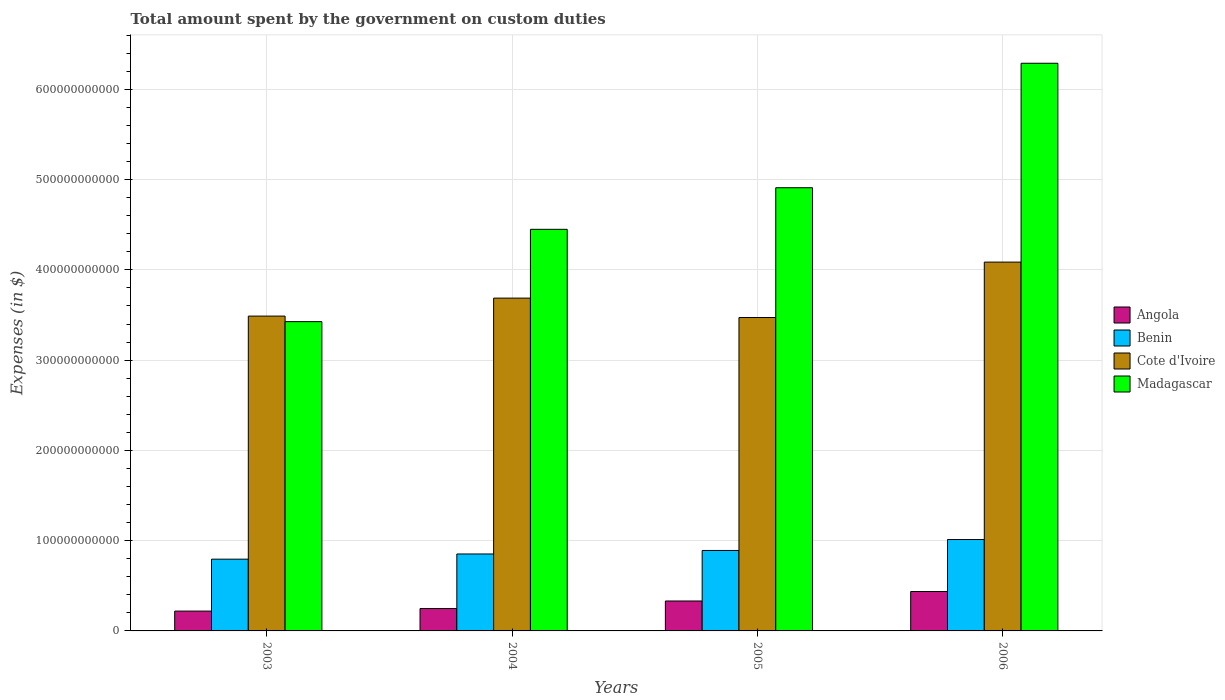Are the number of bars per tick equal to the number of legend labels?
Your answer should be very brief. Yes. Are the number of bars on each tick of the X-axis equal?
Your answer should be compact. Yes. What is the label of the 4th group of bars from the left?
Your response must be concise. 2006. What is the amount spent on custom duties by the government in Madagascar in 2006?
Provide a succinct answer. 6.29e+11. Across all years, what is the maximum amount spent on custom duties by the government in Madagascar?
Make the answer very short. 6.29e+11. Across all years, what is the minimum amount spent on custom duties by the government in Cote d'Ivoire?
Keep it short and to the point. 3.47e+11. In which year was the amount spent on custom duties by the government in Angola maximum?
Provide a short and direct response. 2006. In which year was the amount spent on custom duties by the government in Cote d'Ivoire minimum?
Give a very brief answer. 2005. What is the total amount spent on custom duties by the government in Cote d'Ivoire in the graph?
Your response must be concise. 1.47e+12. What is the difference between the amount spent on custom duties by the government in Cote d'Ivoire in 2005 and that in 2006?
Provide a succinct answer. -6.14e+1. What is the difference between the amount spent on custom duties by the government in Cote d'Ivoire in 2003 and the amount spent on custom duties by the government in Angola in 2005?
Make the answer very short. 3.16e+11. What is the average amount spent on custom duties by the government in Cote d'Ivoire per year?
Provide a short and direct response. 3.68e+11. In the year 2004, what is the difference between the amount spent on custom duties by the government in Cote d'Ivoire and amount spent on custom duties by the government in Madagascar?
Offer a very short reply. -7.62e+1. In how many years, is the amount spent on custom duties by the government in Angola greater than 600000000000 $?
Provide a succinct answer. 0. What is the ratio of the amount spent on custom duties by the government in Madagascar in 2003 to that in 2005?
Your answer should be very brief. 0.7. Is the difference between the amount spent on custom duties by the government in Cote d'Ivoire in 2003 and 2006 greater than the difference between the amount spent on custom duties by the government in Madagascar in 2003 and 2006?
Make the answer very short. Yes. What is the difference between the highest and the second highest amount spent on custom duties by the government in Cote d'Ivoire?
Your answer should be very brief. 3.99e+1. What is the difference between the highest and the lowest amount spent on custom duties by the government in Cote d'Ivoire?
Ensure brevity in your answer.  6.14e+1. In how many years, is the amount spent on custom duties by the government in Madagascar greater than the average amount spent on custom duties by the government in Madagascar taken over all years?
Provide a short and direct response. 2. What does the 4th bar from the left in 2006 represents?
Your response must be concise. Madagascar. What does the 1st bar from the right in 2004 represents?
Your answer should be compact. Madagascar. How many bars are there?
Offer a very short reply. 16. How many years are there in the graph?
Provide a succinct answer. 4. What is the difference between two consecutive major ticks on the Y-axis?
Ensure brevity in your answer.  1.00e+11. Are the values on the major ticks of Y-axis written in scientific E-notation?
Ensure brevity in your answer.  No. Does the graph contain any zero values?
Your answer should be very brief. No. Where does the legend appear in the graph?
Ensure brevity in your answer.  Center right. How are the legend labels stacked?
Give a very brief answer. Vertical. What is the title of the graph?
Your response must be concise. Total amount spent by the government on custom duties. What is the label or title of the X-axis?
Your answer should be compact. Years. What is the label or title of the Y-axis?
Offer a terse response. Expenses (in $). What is the Expenses (in $) of Angola in 2003?
Provide a succinct answer. 2.20e+1. What is the Expenses (in $) of Benin in 2003?
Keep it short and to the point. 7.95e+1. What is the Expenses (in $) in Cote d'Ivoire in 2003?
Provide a short and direct response. 3.49e+11. What is the Expenses (in $) of Madagascar in 2003?
Offer a terse response. 3.43e+11. What is the Expenses (in $) in Angola in 2004?
Offer a terse response. 2.48e+1. What is the Expenses (in $) of Benin in 2004?
Provide a short and direct response. 8.52e+1. What is the Expenses (in $) of Cote d'Ivoire in 2004?
Keep it short and to the point. 3.69e+11. What is the Expenses (in $) in Madagascar in 2004?
Offer a very short reply. 4.45e+11. What is the Expenses (in $) in Angola in 2005?
Make the answer very short. 3.32e+1. What is the Expenses (in $) of Benin in 2005?
Give a very brief answer. 8.91e+1. What is the Expenses (in $) in Cote d'Ivoire in 2005?
Your answer should be very brief. 3.47e+11. What is the Expenses (in $) in Madagascar in 2005?
Your answer should be very brief. 4.91e+11. What is the Expenses (in $) of Angola in 2006?
Provide a succinct answer. 4.37e+1. What is the Expenses (in $) in Benin in 2006?
Provide a succinct answer. 1.01e+11. What is the Expenses (in $) of Cote d'Ivoire in 2006?
Give a very brief answer. 4.09e+11. What is the Expenses (in $) in Madagascar in 2006?
Your answer should be compact. 6.29e+11. Across all years, what is the maximum Expenses (in $) of Angola?
Make the answer very short. 4.37e+1. Across all years, what is the maximum Expenses (in $) in Benin?
Provide a succinct answer. 1.01e+11. Across all years, what is the maximum Expenses (in $) of Cote d'Ivoire?
Ensure brevity in your answer.  4.09e+11. Across all years, what is the maximum Expenses (in $) of Madagascar?
Provide a short and direct response. 6.29e+11. Across all years, what is the minimum Expenses (in $) of Angola?
Your response must be concise. 2.20e+1. Across all years, what is the minimum Expenses (in $) of Benin?
Your answer should be very brief. 7.95e+1. Across all years, what is the minimum Expenses (in $) of Cote d'Ivoire?
Give a very brief answer. 3.47e+11. Across all years, what is the minimum Expenses (in $) in Madagascar?
Offer a very short reply. 3.43e+11. What is the total Expenses (in $) in Angola in the graph?
Offer a terse response. 1.24e+11. What is the total Expenses (in $) in Benin in the graph?
Give a very brief answer. 3.55e+11. What is the total Expenses (in $) in Cote d'Ivoire in the graph?
Ensure brevity in your answer.  1.47e+12. What is the total Expenses (in $) in Madagascar in the graph?
Keep it short and to the point. 1.91e+12. What is the difference between the Expenses (in $) in Angola in 2003 and that in 2004?
Your response must be concise. -2.82e+09. What is the difference between the Expenses (in $) of Benin in 2003 and that in 2004?
Make the answer very short. -5.75e+09. What is the difference between the Expenses (in $) in Cote d'Ivoire in 2003 and that in 2004?
Offer a very short reply. -1.99e+1. What is the difference between the Expenses (in $) in Madagascar in 2003 and that in 2004?
Your answer should be very brief. -1.02e+11. What is the difference between the Expenses (in $) of Angola in 2003 and that in 2005?
Offer a very short reply. -1.12e+1. What is the difference between the Expenses (in $) in Benin in 2003 and that in 2005?
Provide a succinct answer. -9.65e+09. What is the difference between the Expenses (in $) in Cote d'Ivoire in 2003 and that in 2005?
Ensure brevity in your answer.  1.60e+09. What is the difference between the Expenses (in $) of Madagascar in 2003 and that in 2005?
Give a very brief answer. -1.48e+11. What is the difference between the Expenses (in $) of Angola in 2003 and that in 2006?
Provide a short and direct response. -2.17e+1. What is the difference between the Expenses (in $) of Benin in 2003 and that in 2006?
Provide a succinct answer. -2.18e+1. What is the difference between the Expenses (in $) of Cote d'Ivoire in 2003 and that in 2006?
Provide a short and direct response. -5.98e+1. What is the difference between the Expenses (in $) in Madagascar in 2003 and that in 2006?
Your answer should be compact. -2.86e+11. What is the difference between the Expenses (in $) in Angola in 2004 and that in 2005?
Provide a short and direct response. -8.36e+09. What is the difference between the Expenses (in $) of Benin in 2004 and that in 2005?
Your answer should be compact. -3.90e+09. What is the difference between the Expenses (in $) of Cote d'Ivoire in 2004 and that in 2005?
Keep it short and to the point. 2.15e+1. What is the difference between the Expenses (in $) in Madagascar in 2004 and that in 2005?
Keep it short and to the point. -4.61e+1. What is the difference between the Expenses (in $) in Angola in 2004 and that in 2006?
Make the answer very short. -1.89e+1. What is the difference between the Expenses (in $) of Benin in 2004 and that in 2006?
Your answer should be compact. -1.60e+1. What is the difference between the Expenses (in $) of Cote d'Ivoire in 2004 and that in 2006?
Provide a short and direct response. -3.99e+1. What is the difference between the Expenses (in $) of Madagascar in 2004 and that in 2006?
Your response must be concise. -1.84e+11. What is the difference between the Expenses (in $) of Angola in 2005 and that in 2006?
Ensure brevity in your answer.  -1.05e+1. What is the difference between the Expenses (in $) of Benin in 2005 and that in 2006?
Provide a short and direct response. -1.21e+1. What is the difference between the Expenses (in $) of Cote d'Ivoire in 2005 and that in 2006?
Your answer should be compact. -6.14e+1. What is the difference between the Expenses (in $) in Madagascar in 2005 and that in 2006?
Make the answer very short. -1.38e+11. What is the difference between the Expenses (in $) in Angola in 2003 and the Expenses (in $) in Benin in 2004?
Your response must be concise. -6.33e+1. What is the difference between the Expenses (in $) in Angola in 2003 and the Expenses (in $) in Cote d'Ivoire in 2004?
Offer a terse response. -3.47e+11. What is the difference between the Expenses (in $) of Angola in 2003 and the Expenses (in $) of Madagascar in 2004?
Keep it short and to the point. -4.23e+11. What is the difference between the Expenses (in $) of Benin in 2003 and the Expenses (in $) of Cote d'Ivoire in 2004?
Provide a succinct answer. -2.89e+11. What is the difference between the Expenses (in $) in Benin in 2003 and the Expenses (in $) in Madagascar in 2004?
Your answer should be very brief. -3.65e+11. What is the difference between the Expenses (in $) in Cote d'Ivoire in 2003 and the Expenses (in $) in Madagascar in 2004?
Offer a terse response. -9.61e+1. What is the difference between the Expenses (in $) in Angola in 2003 and the Expenses (in $) in Benin in 2005?
Keep it short and to the point. -6.72e+1. What is the difference between the Expenses (in $) of Angola in 2003 and the Expenses (in $) of Cote d'Ivoire in 2005?
Give a very brief answer. -3.25e+11. What is the difference between the Expenses (in $) in Angola in 2003 and the Expenses (in $) in Madagascar in 2005?
Give a very brief answer. -4.69e+11. What is the difference between the Expenses (in $) in Benin in 2003 and the Expenses (in $) in Cote d'Ivoire in 2005?
Make the answer very short. -2.68e+11. What is the difference between the Expenses (in $) of Benin in 2003 and the Expenses (in $) of Madagascar in 2005?
Provide a succinct answer. -4.12e+11. What is the difference between the Expenses (in $) in Cote d'Ivoire in 2003 and the Expenses (in $) in Madagascar in 2005?
Give a very brief answer. -1.42e+11. What is the difference between the Expenses (in $) in Angola in 2003 and the Expenses (in $) in Benin in 2006?
Your answer should be compact. -7.93e+1. What is the difference between the Expenses (in $) in Angola in 2003 and the Expenses (in $) in Cote d'Ivoire in 2006?
Your response must be concise. -3.87e+11. What is the difference between the Expenses (in $) in Angola in 2003 and the Expenses (in $) in Madagascar in 2006?
Ensure brevity in your answer.  -6.07e+11. What is the difference between the Expenses (in $) of Benin in 2003 and the Expenses (in $) of Cote d'Ivoire in 2006?
Your response must be concise. -3.29e+11. What is the difference between the Expenses (in $) in Benin in 2003 and the Expenses (in $) in Madagascar in 2006?
Your answer should be compact. -5.49e+11. What is the difference between the Expenses (in $) of Cote d'Ivoire in 2003 and the Expenses (in $) of Madagascar in 2006?
Offer a terse response. -2.80e+11. What is the difference between the Expenses (in $) in Angola in 2004 and the Expenses (in $) in Benin in 2005?
Your response must be concise. -6.44e+1. What is the difference between the Expenses (in $) in Angola in 2004 and the Expenses (in $) in Cote d'Ivoire in 2005?
Provide a succinct answer. -3.22e+11. What is the difference between the Expenses (in $) of Angola in 2004 and the Expenses (in $) of Madagascar in 2005?
Make the answer very short. -4.66e+11. What is the difference between the Expenses (in $) of Benin in 2004 and the Expenses (in $) of Cote d'Ivoire in 2005?
Provide a succinct answer. -2.62e+11. What is the difference between the Expenses (in $) in Benin in 2004 and the Expenses (in $) in Madagascar in 2005?
Your answer should be compact. -4.06e+11. What is the difference between the Expenses (in $) of Cote d'Ivoire in 2004 and the Expenses (in $) of Madagascar in 2005?
Keep it short and to the point. -1.22e+11. What is the difference between the Expenses (in $) of Angola in 2004 and the Expenses (in $) of Benin in 2006?
Give a very brief answer. -7.65e+1. What is the difference between the Expenses (in $) in Angola in 2004 and the Expenses (in $) in Cote d'Ivoire in 2006?
Offer a very short reply. -3.84e+11. What is the difference between the Expenses (in $) of Angola in 2004 and the Expenses (in $) of Madagascar in 2006?
Make the answer very short. -6.04e+11. What is the difference between the Expenses (in $) in Benin in 2004 and the Expenses (in $) in Cote d'Ivoire in 2006?
Give a very brief answer. -3.23e+11. What is the difference between the Expenses (in $) of Benin in 2004 and the Expenses (in $) of Madagascar in 2006?
Offer a terse response. -5.44e+11. What is the difference between the Expenses (in $) of Cote d'Ivoire in 2004 and the Expenses (in $) of Madagascar in 2006?
Your response must be concise. -2.60e+11. What is the difference between the Expenses (in $) of Angola in 2005 and the Expenses (in $) of Benin in 2006?
Make the answer very short. -6.81e+1. What is the difference between the Expenses (in $) of Angola in 2005 and the Expenses (in $) of Cote d'Ivoire in 2006?
Your response must be concise. -3.75e+11. What is the difference between the Expenses (in $) of Angola in 2005 and the Expenses (in $) of Madagascar in 2006?
Your response must be concise. -5.96e+11. What is the difference between the Expenses (in $) of Benin in 2005 and the Expenses (in $) of Cote d'Ivoire in 2006?
Offer a terse response. -3.19e+11. What is the difference between the Expenses (in $) of Benin in 2005 and the Expenses (in $) of Madagascar in 2006?
Provide a short and direct response. -5.40e+11. What is the difference between the Expenses (in $) of Cote d'Ivoire in 2005 and the Expenses (in $) of Madagascar in 2006?
Ensure brevity in your answer.  -2.82e+11. What is the average Expenses (in $) in Angola per year?
Offer a very short reply. 3.09e+1. What is the average Expenses (in $) in Benin per year?
Provide a succinct answer. 8.88e+1. What is the average Expenses (in $) of Cote d'Ivoire per year?
Your response must be concise. 3.68e+11. What is the average Expenses (in $) of Madagascar per year?
Make the answer very short. 4.77e+11. In the year 2003, what is the difference between the Expenses (in $) of Angola and Expenses (in $) of Benin?
Give a very brief answer. -5.75e+1. In the year 2003, what is the difference between the Expenses (in $) in Angola and Expenses (in $) in Cote d'Ivoire?
Your answer should be very brief. -3.27e+11. In the year 2003, what is the difference between the Expenses (in $) in Angola and Expenses (in $) in Madagascar?
Offer a terse response. -3.21e+11. In the year 2003, what is the difference between the Expenses (in $) in Benin and Expenses (in $) in Cote d'Ivoire?
Ensure brevity in your answer.  -2.69e+11. In the year 2003, what is the difference between the Expenses (in $) in Benin and Expenses (in $) in Madagascar?
Provide a short and direct response. -2.63e+11. In the year 2003, what is the difference between the Expenses (in $) in Cote d'Ivoire and Expenses (in $) in Madagascar?
Offer a terse response. 6.17e+09. In the year 2004, what is the difference between the Expenses (in $) in Angola and Expenses (in $) in Benin?
Make the answer very short. -6.05e+1. In the year 2004, what is the difference between the Expenses (in $) in Angola and Expenses (in $) in Cote d'Ivoire?
Your answer should be compact. -3.44e+11. In the year 2004, what is the difference between the Expenses (in $) of Angola and Expenses (in $) of Madagascar?
Offer a very short reply. -4.20e+11. In the year 2004, what is the difference between the Expenses (in $) in Benin and Expenses (in $) in Cote d'Ivoire?
Provide a succinct answer. -2.83e+11. In the year 2004, what is the difference between the Expenses (in $) of Benin and Expenses (in $) of Madagascar?
Provide a succinct answer. -3.60e+11. In the year 2004, what is the difference between the Expenses (in $) in Cote d'Ivoire and Expenses (in $) in Madagascar?
Offer a terse response. -7.62e+1. In the year 2005, what is the difference between the Expenses (in $) of Angola and Expenses (in $) of Benin?
Keep it short and to the point. -5.60e+1. In the year 2005, what is the difference between the Expenses (in $) in Angola and Expenses (in $) in Cote d'Ivoire?
Your answer should be compact. -3.14e+11. In the year 2005, what is the difference between the Expenses (in $) of Angola and Expenses (in $) of Madagascar?
Offer a terse response. -4.58e+11. In the year 2005, what is the difference between the Expenses (in $) in Benin and Expenses (in $) in Cote d'Ivoire?
Offer a terse response. -2.58e+11. In the year 2005, what is the difference between the Expenses (in $) of Benin and Expenses (in $) of Madagascar?
Provide a succinct answer. -4.02e+11. In the year 2005, what is the difference between the Expenses (in $) of Cote d'Ivoire and Expenses (in $) of Madagascar?
Keep it short and to the point. -1.44e+11. In the year 2006, what is the difference between the Expenses (in $) of Angola and Expenses (in $) of Benin?
Make the answer very short. -5.76e+1. In the year 2006, what is the difference between the Expenses (in $) of Angola and Expenses (in $) of Cote d'Ivoire?
Your response must be concise. -3.65e+11. In the year 2006, what is the difference between the Expenses (in $) in Angola and Expenses (in $) in Madagascar?
Your response must be concise. -5.85e+11. In the year 2006, what is the difference between the Expenses (in $) of Benin and Expenses (in $) of Cote d'Ivoire?
Keep it short and to the point. -3.07e+11. In the year 2006, what is the difference between the Expenses (in $) of Benin and Expenses (in $) of Madagascar?
Provide a short and direct response. -5.28e+11. In the year 2006, what is the difference between the Expenses (in $) of Cote d'Ivoire and Expenses (in $) of Madagascar?
Keep it short and to the point. -2.20e+11. What is the ratio of the Expenses (in $) of Angola in 2003 to that in 2004?
Provide a short and direct response. 0.89. What is the ratio of the Expenses (in $) in Benin in 2003 to that in 2004?
Offer a very short reply. 0.93. What is the ratio of the Expenses (in $) in Cote d'Ivoire in 2003 to that in 2004?
Make the answer very short. 0.95. What is the ratio of the Expenses (in $) in Madagascar in 2003 to that in 2004?
Your answer should be compact. 0.77. What is the ratio of the Expenses (in $) of Angola in 2003 to that in 2005?
Provide a succinct answer. 0.66. What is the ratio of the Expenses (in $) of Benin in 2003 to that in 2005?
Give a very brief answer. 0.89. What is the ratio of the Expenses (in $) in Cote d'Ivoire in 2003 to that in 2005?
Offer a terse response. 1. What is the ratio of the Expenses (in $) in Madagascar in 2003 to that in 2005?
Offer a terse response. 0.7. What is the ratio of the Expenses (in $) in Angola in 2003 to that in 2006?
Make the answer very short. 0.5. What is the ratio of the Expenses (in $) in Benin in 2003 to that in 2006?
Provide a short and direct response. 0.79. What is the ratio of the Expenses (in $) of Cote d'Ivoire in 2003 to that in 2006?
Provide a short and direct response. 0.85. What is the ratio of the Expenses (in $) of Madagascar in 2003 to that in 2006?
Your answer should be very brief. 0.54. What is the ratio of the Expenses (in $) in Angola in 2004 to that in 2005?
Make the answer very short. 0.75. What is the ratio of the Expenses (in $) of Benin in 2004 to that in 2005?
Offer a terse response. 0.96. What is the ratio of the Expenses (in $) of Cote d'Ivoire in 2004 to that in 2005?
Your response must be concise. 1.06. What is the ratio of the Expenses (in $) of Madagascar in 2004 to that in 2005?
Provide a short and direct response. 0.91. What is the ratio of the Expenses (in $) in Angola in 2004 to that in 2006?
Give a very brief answer. 0.57. What is the ratio of the Expenses (in $) in Benin in 2004 to that in 2006?
Give a very brief answer. 0.84. What is the ratio of the Expenses (in $) in Cote d'Ivoire in 2004 to that in 2006?
Make the answer very short. 0.9. What is the ratio of the Expenses (in $) of Madagascar in 2004 to that in 2006?
Keep it short and to the point. 0.71. What is the ratio of the Expenses (in $) of Angola in 2005 to that in 2006?
Ensure brevity in your answer.  0.76. What is the ratio of the Expenses (in $) of Benin in 2005 to that in 2006?
Provide a short and direct response. 0.88. What is the ratio of the Expenses (in $) of Cote d'Ivoire in 2005 to that in 2006?
Offer a terse response. 0.85. What is the ratio of the Expenses (in $) in Madagascar in 2005 to that in 2006?
Make the answer very short. 0.78. What is the difference between the highest and the second highest Expenses (in $) in Angola?
Ensure brevity in your answer.  1.05e+1. What is the difference between the highest and the second highest Expenses (in $) of Benin?
Offer a very short reply. 1.21e+1. What is the difference between the highest and the second highest Expenses (in $) in Cote d'Ivoire?
Offer a terse response. 3.99e+1. What is the difference between the highest and the second highest Expenses (in $) in Madagascar?
Your answer should be very brief. 1.38e+11. What is the difference between the highest and the lowest Expenses (in $) in Angola?
Offer a terse response. 2.17e+1. What is the difference between the highest and the lowest Expenses (in $) of Benin?
Ensure brevity in your answer.  2.18e+1. What is the difference between the highest and the lowest Expenses (in $) in Cote d'Ivoire?
Offer a very short reply. 6.14e+1. What is the difference between the highest and the lowest Expenses (in $) in Madagascar?
Provide a short and direct response. 2.86e+11. 